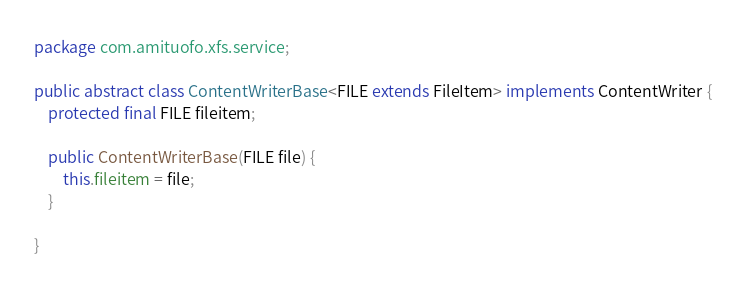<code> <loc_0><loc_0><loc_500><loc_500><_Java_>package com.amituofo.xfs.service;

public abstract class ContentWriterBase<FILE extends FileItem> implements ContentWriter {
	protected final FILE fileitem;

	public ContentWriterBase(FILE file) {
		this.fileitem = file;
	}
	
}
</code> 